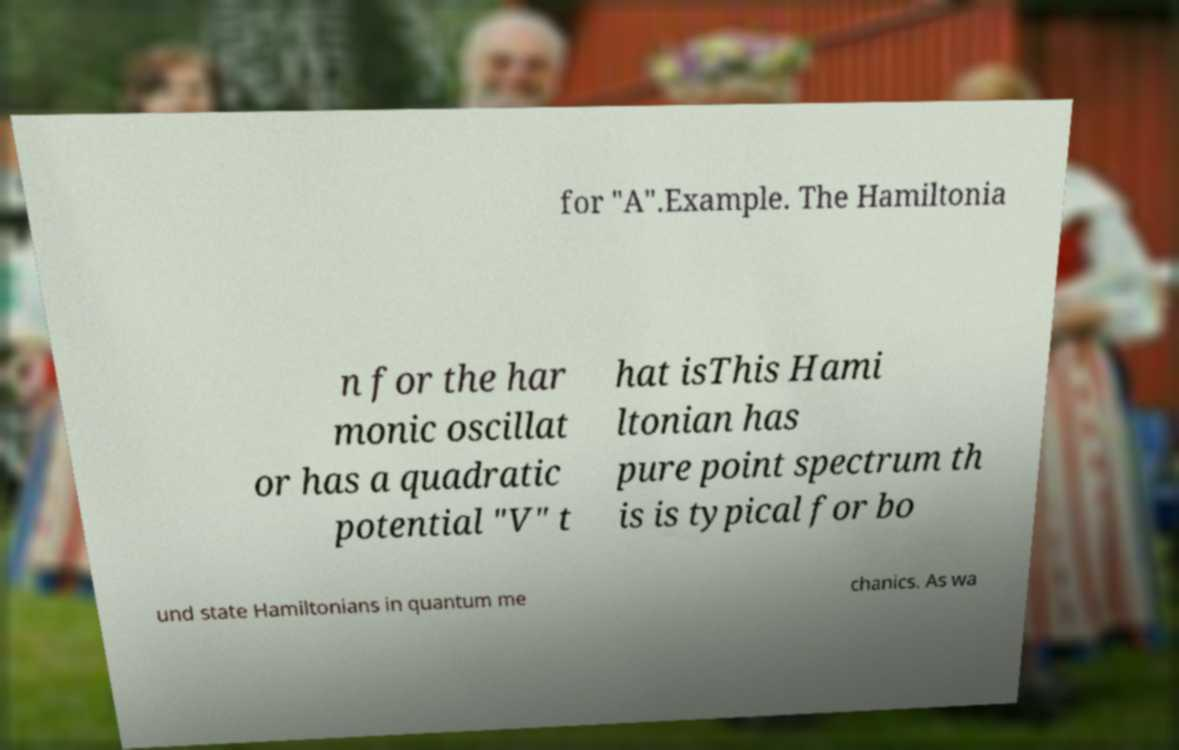I need the written content from this picture converted into text. Can you do that? for "A".Example. The Hamiltonia n for the har monic oscillat or has a quadratic potential "V" t hat isThis Hami ltonian has pure point spectrum th is is typical for bo und state Hamiltonians in quantum me chanics. As wa 